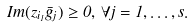Convert formula to latex. <formula><loc_0><loc_0><loc_500><loc_500>I m ( z _ { i _ { 1 } } \bar { g } _ { j } ) \geq 0 , \, \forall j = 1 , \dots , s .</formula> 